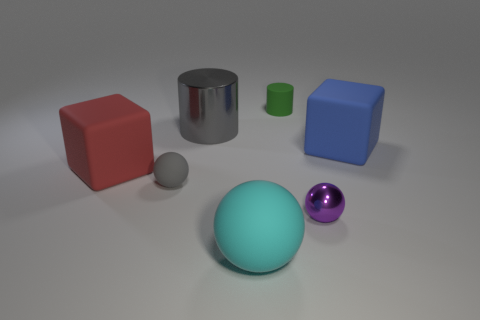Add 2 large brown metal balls. How many objects exist? 9 Subtract all cylinders. How many objects are left? 5 Subtract 1 red cubes. How many objects are left? 6 Subtract all large red rubber blocks. Subtract all blue objects. How many objects are left? 5 Add 7 small purple objects. How many small purple objects are left? 8 Add 6 small cylinders. How many small cylinders exist? 7 